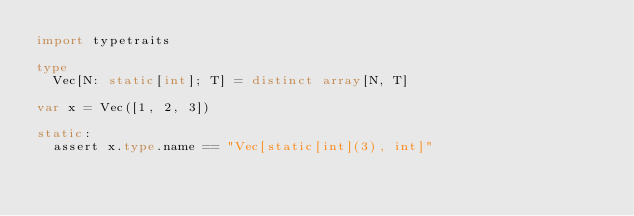Convert code to text. <code><loc_0><loc_0><loc_500><loc_500><_Nim_>import typetraits

type
  Vec[N: static[int]; T] = distinct array[N, T]

var x = Vec([1, 2, 3])

static:
  assert x.type.name == "Vec[static[int](3), int]"

</code> 